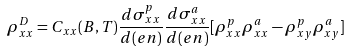Convert formula to latex. <formula><loc_0><loc_0><loc_500><loc_500>\rho ^ { D } _ { x x } = C _ { x x } ( B , T ) \frac { d \sigma ^ { p } _ { x x } } { d ( e n ) } \frac { d \sigma ^ { a } _ { x x } } { d ( e n ) } [ \rho ^ { p } _ { x x } \rho ^ { a } _ { x x } - \rho ^ { p } _ { x y } \rho ^ { a } _ { x y } ]</formula> 